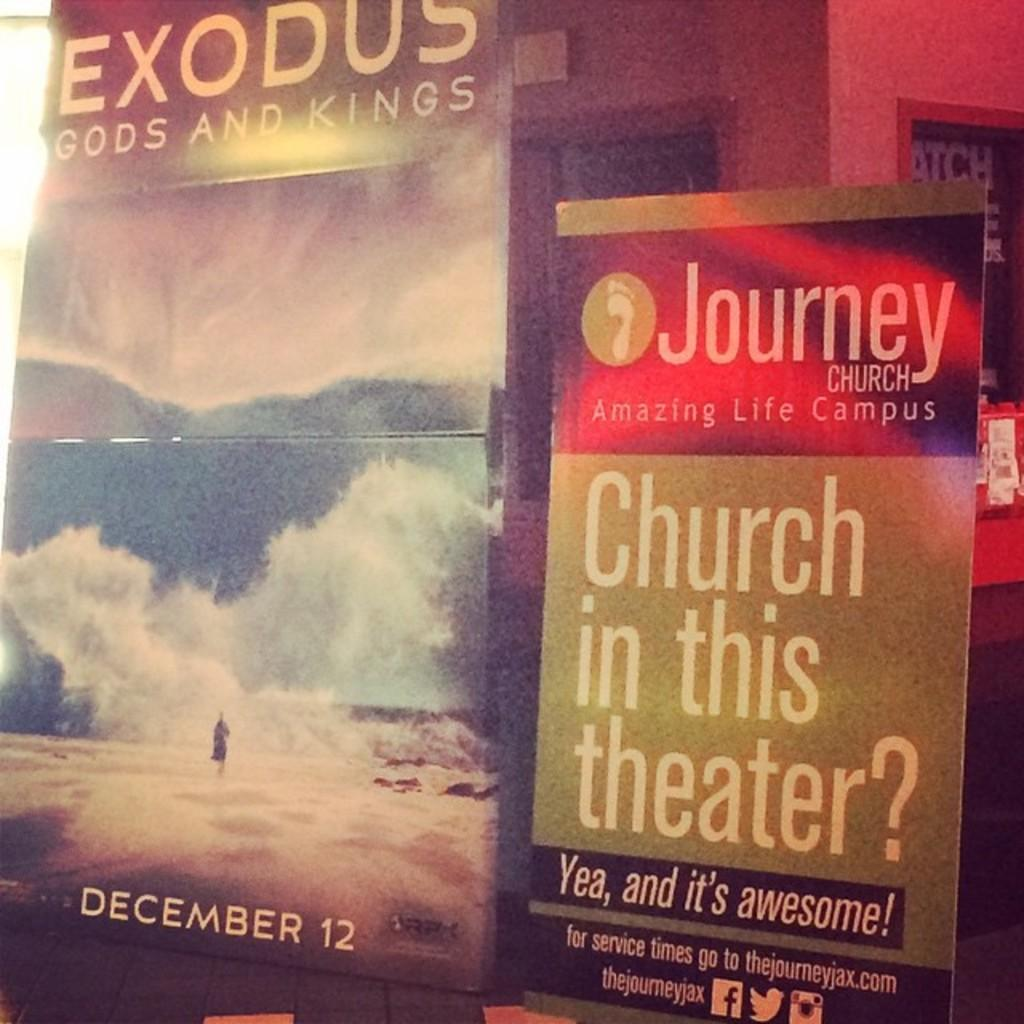<image>
Present a compact description of the photo's key features. In a room there is a poster that says Church in this theater. 